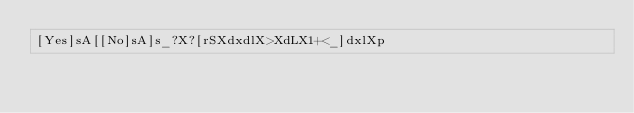<code> <loc_0><loc_0><loc_500><loc_500><_dc_>[Yes]sA[[No]sA]s_?X?[rSXdxdlX>XdLX1+<_]dxlXp</code> 